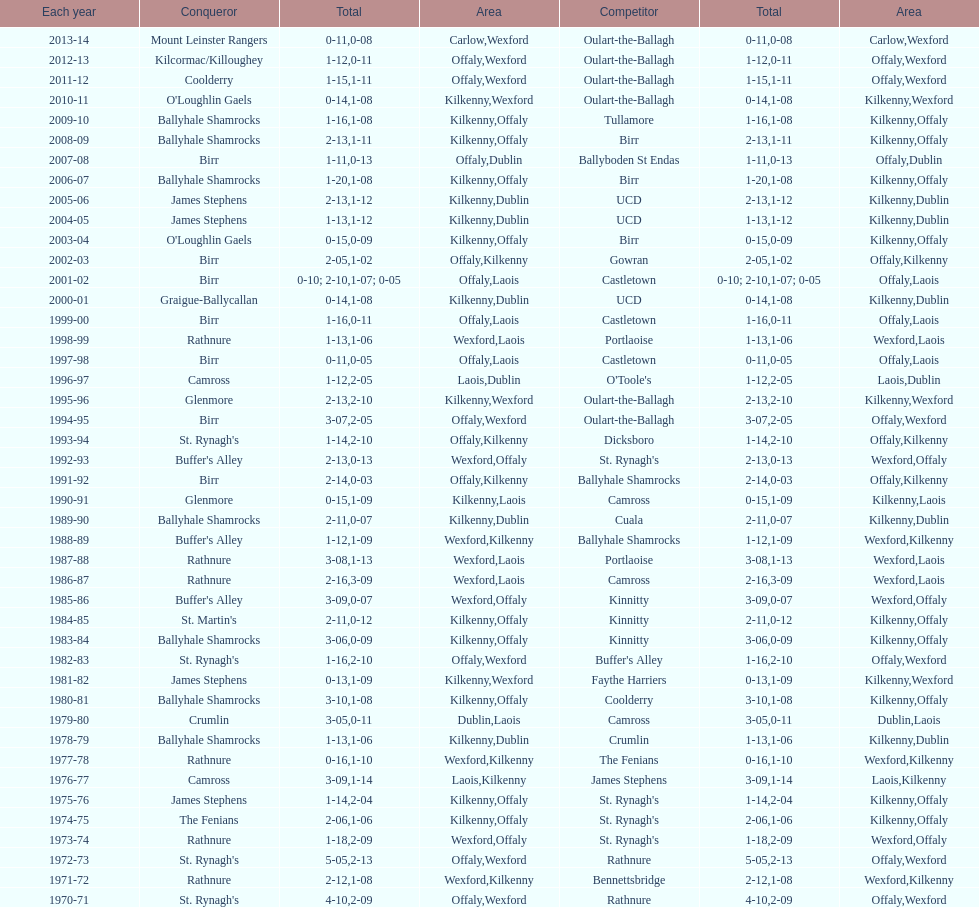How many consecutive years did rathnure win? 2. 